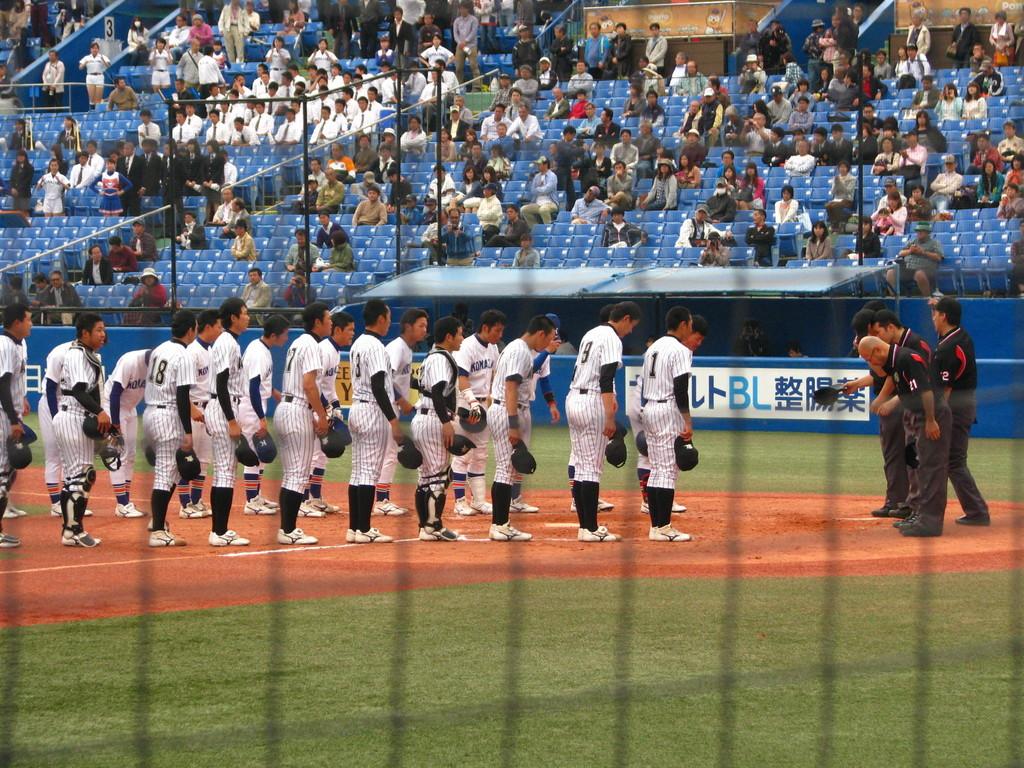What two letters are in light blue?
Your response must be concise. Bl. What number is on the player closest to the umpire?
Keep it short and to the point. 1. 